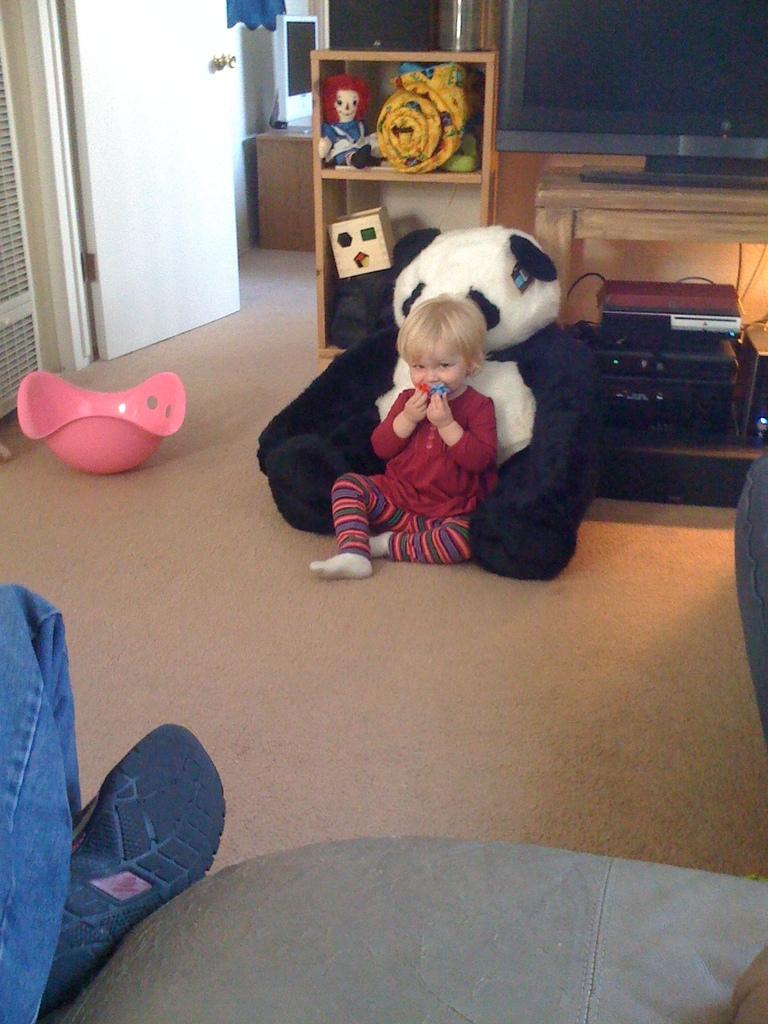Can you describe this image briefly? In the middle of this image, there is a child in red color t-shirt, sitting on the floor. Behind this child, there is a doll on the floor. On the left side, there is a person in a jean pant. In the background, there are toys arranged on the shelves, there is a pink color bowl, a television on a wooden table, there is a door, a screen and there are other objects. 